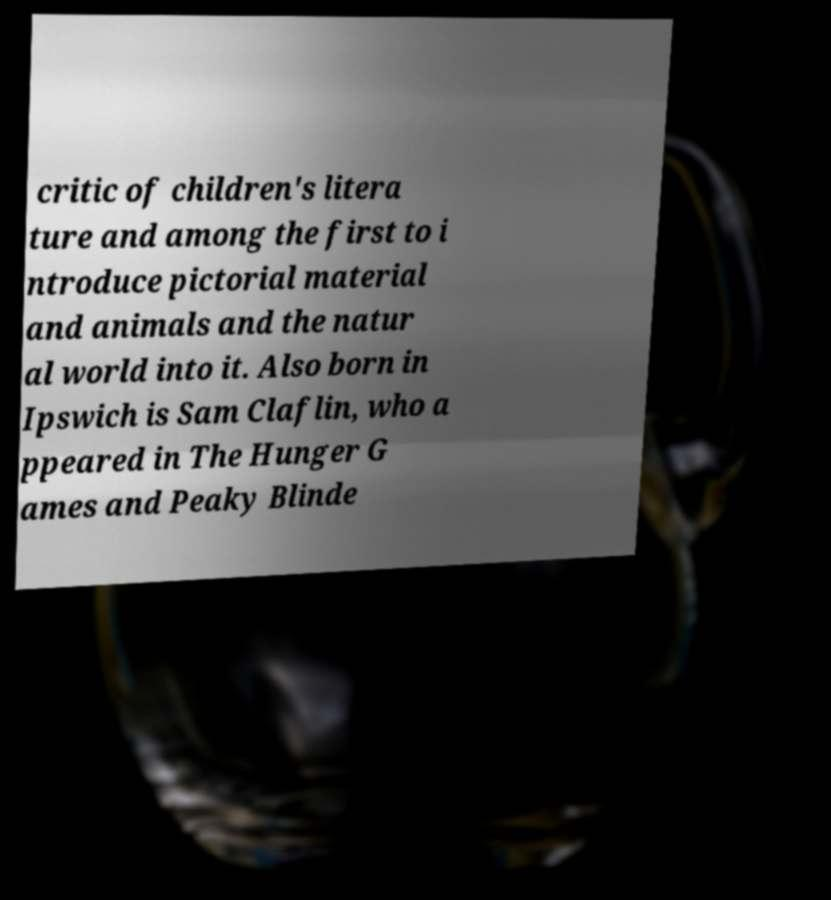Can you read and provide the text displayed in the image?This photo seems to have some interesting text. Can you extract and type it out for me? critic of children's litera ture and among the first to i ntroduce pictorial material and animals and the natur al world into it. Also born in Ipswich is Sam Claflin, who a ppeared in The Hunger G ames and Peaky Blinde 